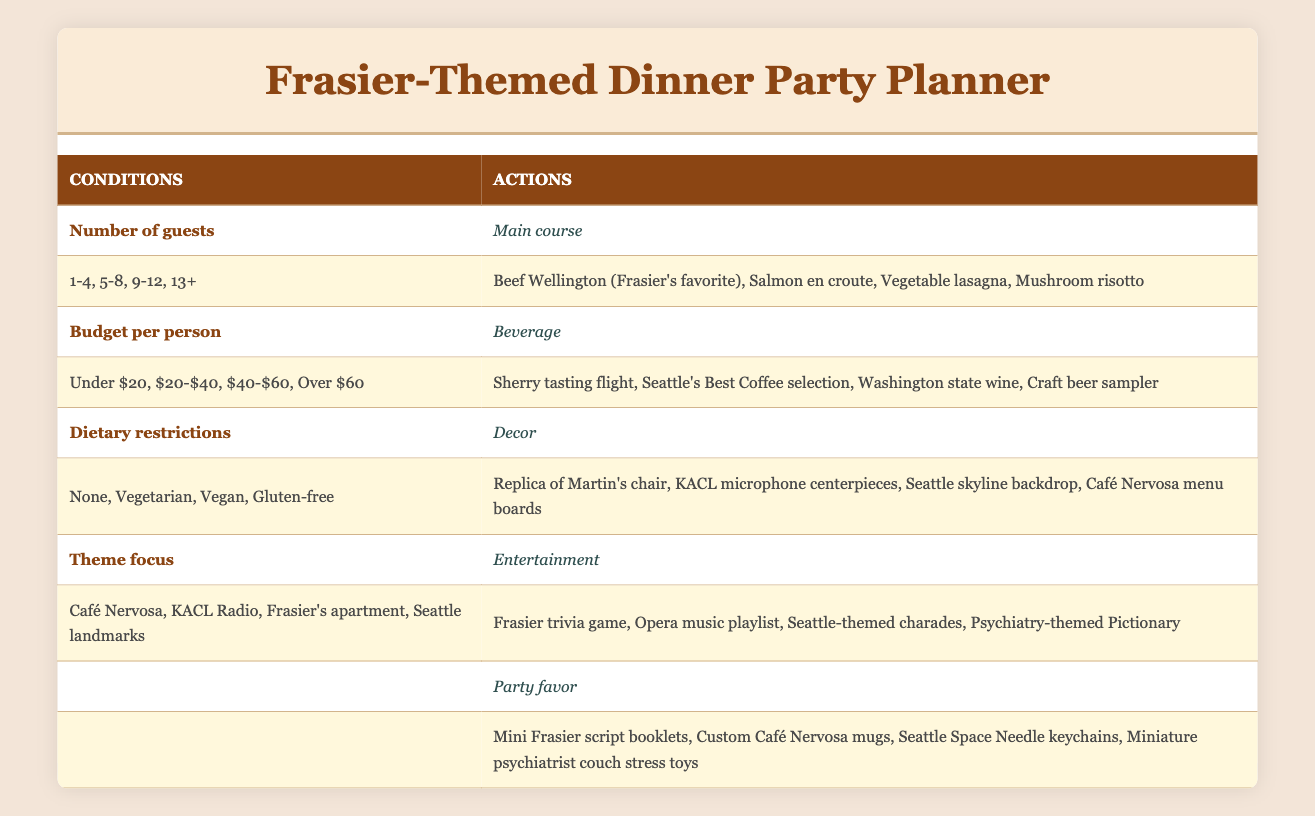What are the options for the main course if there are 5-8 guests? According to the table, for the range of 5-8 guests, the main course options listed are Beef Wellington, Salmon en croute, Vegetable lasagna, and Mushroom risotto.
Answer: Beef Wellington, Salmon en croute, Vegetable lasagna, Mushroom risotto Is there a beverage option for a budget between $20 and $40? Yes, the table indicates that for a budget range of $20-$40, the beverage option is Washington state wine alongside other options.
Answer: Yes Which party favor options are available for guests with vegan dietary restrictions? The table does not specify dietary restrictions directly tied to party favors. However, it lists possible party favors which include Mini Frasier script booklets, Custom Café Nervosa mugs, Seattle Space Needle keychains, and Miniature psychiatrist couch stress toys, all of which are likely to be suitable for various dietary restrictions.
Answer: Mini Frasier script booklets, Custom Café Nervosa mugs, Seattle Space Needle keychains, Miniature psychiatrist couch stress toys What is the main course if the theme focus is on KACL Radio? For a focus on KACL Radio, the table lists the main course options as Beef Wellington, Salmon en croute, Vegetable lasagna, and Mushroom risotto. Therefore, any of these can be selected, but the table doesn't link a specific main course with KACL Radio.
Answer: Beef Wellington, Salmon en croute, Vegetable lasagna, Mushroom risotto What is the required average budget per person to obtain the craft beer sampler beverage option? The craft beer sampler is listed under the "Over $60" category for budget per person in the table, which indicates that to get this beverage option, the average budget per person should be above $60.
Answer: Over $60 Can you have a meal with no dietary restrictions and still choose a vegetarian main course? No, the options for the main course are linked to dietary restrictions. If there are no dietary restrictions, you can only choose among the options provided – which do include Beef Wellington, Salmon en croute, Vegetable lasagna, and Mushroom risotto, but the vegetarian option would not apply if no restrictions are specified.
Answer: No If there are 9-12 guests, what beverage is not an option? For the range of 9-12 guests, the beverage options listed are Sherry tasting flight, Seattle's Best Coffee selection, Washington state wine, and Craft beer sampler. Therefore, none of these options can be excluded. However, it’s not clear which option might be deemed "not an option" specifically.
Answer: None How many entertainment options are listed for the theme focus of Seattle landmarks? The table lists four entertainment options for the Seattle landmarks theme: Frasier trivia game, Opera music playlist, Seattle-themed charades, and Psychiatry-themed Pictionary. Therefore, the count is four options available.
Answer: Four options 